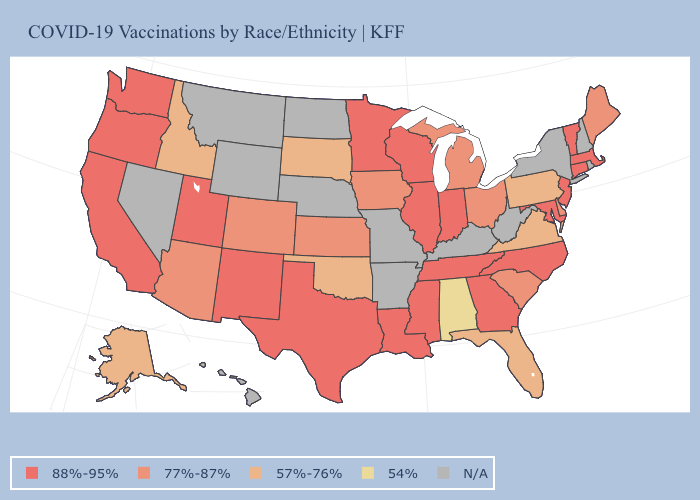Does Ohio have the highest value in the USA?
Concise answer only. No. Which states have the lowest value in the MidWest?
Answer briefly. South Dakota. Name the states that have a value in the range 77%-87%?
Keep it brief. Arizona, Colorado, Delaware, Iowa, Kansas, Maine, Michigan, Ohio, South Carolina. What is the highest value in the MidWest ?
Be succinct. 88%-95%. Which states hav the highest value in the South?
Give a very brief answer. Georgia, Louisiana, Maryland, Mississippi, North Carolina, Tennessee, Texas. What is the value of Utah?
Give a very brief answer. 88%-95%. Name the states that have a value in the range 57%-76%?
Short answer required. Alaska, Florida, Idaho, Oklahoma, Pennsylvania, South Dakota, Virginia. What is the value of Louisiana?
Write a very short answer. 88%-95%. Does New Mexico have the lowest value in the West?
Give a very brief answer. No. Does Utah have the lowest value in the USA?
Write a very short answer. No. What is the highest value in the MidWest ?
Write a very short answer. 88%-95%. Among the states that border Kansas , which have the lowest value?
Quick response, please. Oklahoma. Which states have the highest value in the USA?
Write a very short answer. California, Connecticut, Georgia, Illinois, Indiana, Louisiana, Maryland, Massachusetts, Minnesota, Mississippi, New Jersey, New Mexico, North Carolina, Oregon, Tennessee, Texas, Utah, Vermont, Washington, Wisconsin. 